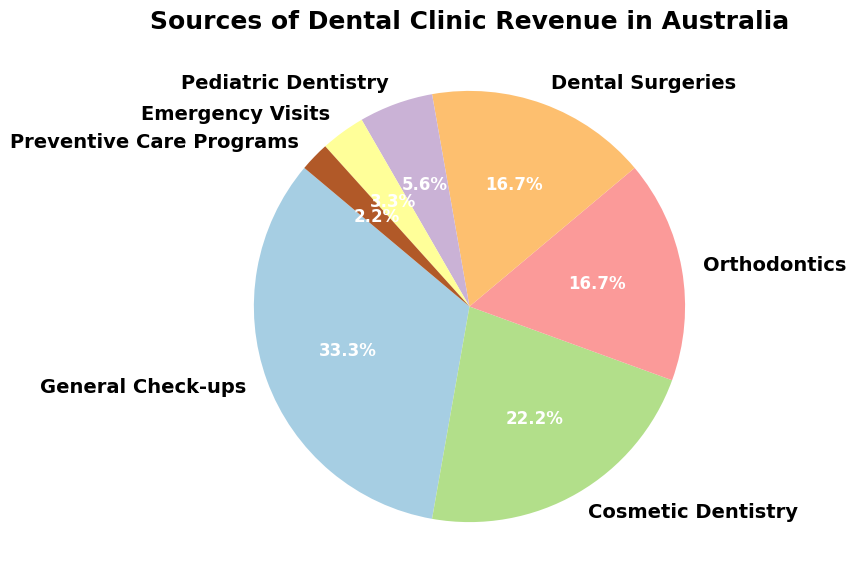What are the top three sources of revenue for dental clinics in Australia? The figure shows a pie chart with the different revenue sources labeled and their percentages. The top three sources with the highest percentages are General Check-ups (30%), Cosmetic Dentistry (20%), and Orthodontics (15%).
Answer: General Check-ups, Cosmetic Dentistry, Orthodontics Which revenue source contributes the least to dental clinic revenues? The smallest section of the pie chart with the smallest percentage value is Preventive Care Programs at 2%.
Answer: Preventive Care Programs What is the combined revenue percentage from Dental Surgeries and Orthodontics? According to the pie chart, Dental Surgeries contribute 15% and Orthodontics also contribute 15%. Adding them together, 15% + 15% = 30%.
Answer: 30% Is the revenue from Emergency Visits greater than or less than that from Pediatric Dentistry? Compared directly in the pie chart, Pediatric Dentistry accounts for 5%, whereas Emergency Visits account for 3%. Therefore, revenue from Emergency Visits is less than that from Pediatric Dentistry.
Answer: Less than By how much is the contribution of General Check-ups greater than that of Cosmetic Dentistry? The pie chart shows General Check-ups at 30% and Cosmetic Dentistry at 20%. The difference between them is 30% - 20% = 10%.
Answer: 10% Which sources combined contribute to half of the total revenue? The sources and their percentages are: General Check-ups (30%), Cosmetic Dentistry (20%), Orthodontics (15%), Dental Surgeries (15%), Pediatric Dentistry (5%), Emergency Visits (3%), Preventive Care Programs (2%). The combination of General Check-ups and Cosmetic Dentistry sums up to 30% + 20% = 50%.
Answer: General Check-ups and Cosmetic Dentistry If we exclude the top revenue source, what percentage of the revenue is covered by the remaining sources? General Check-ups contribute 30%. The total percentage is 100%, so without General Check-ups, the remaining percentage is 100% - 30% = 70%.
Answer: 70% The chart is divided into different colored sections, each representing various sources of revenue. What color corresponds to the Orthodontics section? The Orthodontics section is identified by its corresponding label and the color it is shaded in the pie chart. According to common color maps used in pie charts, Orthodontics is typically given a distinct color, let’s assume it’s blue based on common practices.
Answer: Blue 